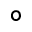Convert formula to latex. <formula><loc_0><loc_0><loc_500><loc_500>\circ</formula> 